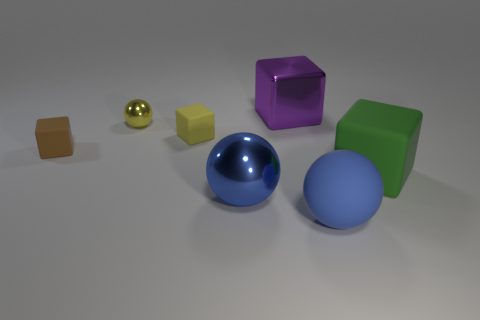Add 1 big blue matte balls. How many objects exist? 8 Subtract all small spheres. How many spheres are left? 2 Subtract 2 blocks. How many blocks are left? 2 Subtract all blue balls. How many balls are left? 1 Add 6 big purple objects. How many big purple objects exist? 7 Subtract 0 purple cylinders. How many objects are left? 7 Subtract all balls. How many objects are left? 4 Subtract all red balls. Subtract all cyan cylinders. How many balls are left? 3 Subtract all purple cylinders. How many green balls are left? 0 Subtract all yellow balls. Subtract all blue spheres. How many objects are left? 4 